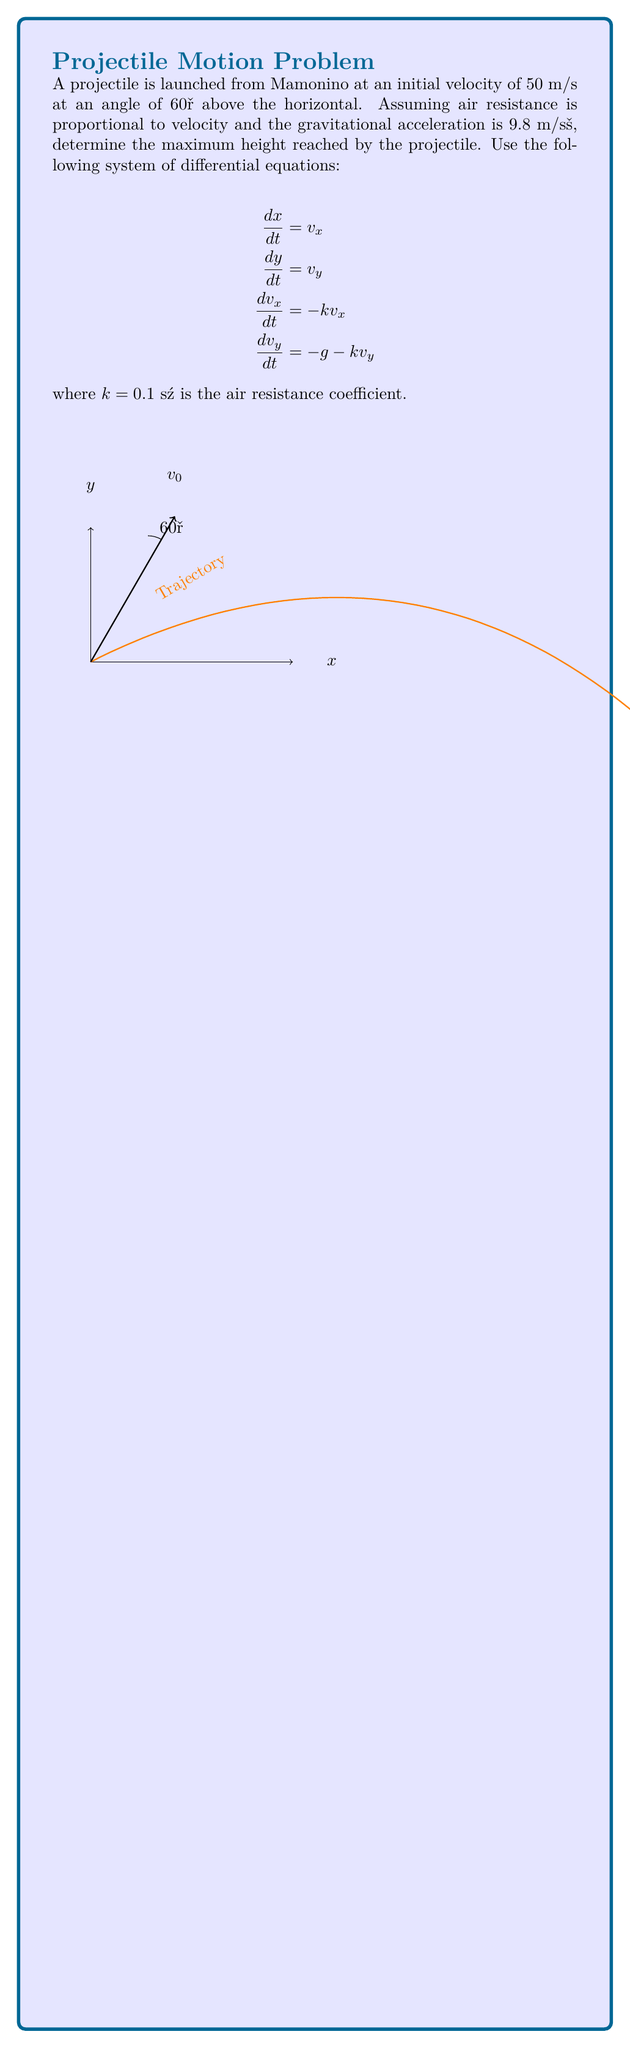Show me your answer to this math problem. Let's approach this step-by-step:

1) First, we need to solve the differential equations for $v_x$ and $v_y$:

   For $v_x$: $\frac{dv_x}{dt} = -kv_x$
   Solving this gives: $v_x = v_{0x}e^{-kt}$, where $v_{0x} = v_0 \cos(60°)$

   For $v_y$: $\frac{dv_y}{dt} = -g - kv_y$
   Solving this gives: $v_y = (v_{0y} + \frac{g}{k})e^{-kt} - \frac{g}{k}$, where $v_{0y} = v_0 \sin(60°)$

2) Now we can solve for $x$ and $y$:

   $x = \int v_x dt = \frac{v_{0x}}{k}(1 - e^{-kt})$

   $y = \int v_y dt = \frac{v_{0y} + \frac{g}{k}}{k}(1 - e^{-kt}) - \frac{g}{k}t$

3) To find the maximum height, we need to find when $v_y = 0$:

   $0 = (v_{0y} + \frac{g}{k})e^{-kt} - \frac{g}{k}$

   Solving for $t$:

   $t_{max} = \frac{1}{k} \ln(1 + \frac{kv_{0y}}{g})$

4) Now we can substitute this $t_{max}$ into our equation for $y$ to get the maximum height:

   $y_{max} = \frac{v_{0y} + \frac{g}{k}}{k}(1 - e^{-kt_{max}}) - \frac{g}{k}t_{max}$

5) Let's substitute our values:
   $v_0 = 50$ m/s
   $\theta = 60°$
   $g = 9.8$ m/s²
   $k = 0.1$ s⁻¹

   $v_{0y} = 50 \sin(60°) \approx 43.3$ m/s

   $t_{max} = \frac{1}{0.1} \ln(1 + \frac{0.1 * 43.3}{9.8}) \approx 3.78$ s

   $y_{max} = \frac{43.3 + \frac{9.8}{0.1}}{0.1}(1 - e^{-0.1*3.78}) - \frac{9.8}{0.1}*3.78 \approx 94.7$ m

Therefore, the maximum height reached by the projectile is approximately 94.7 meters.
Answer: 94.7 m 